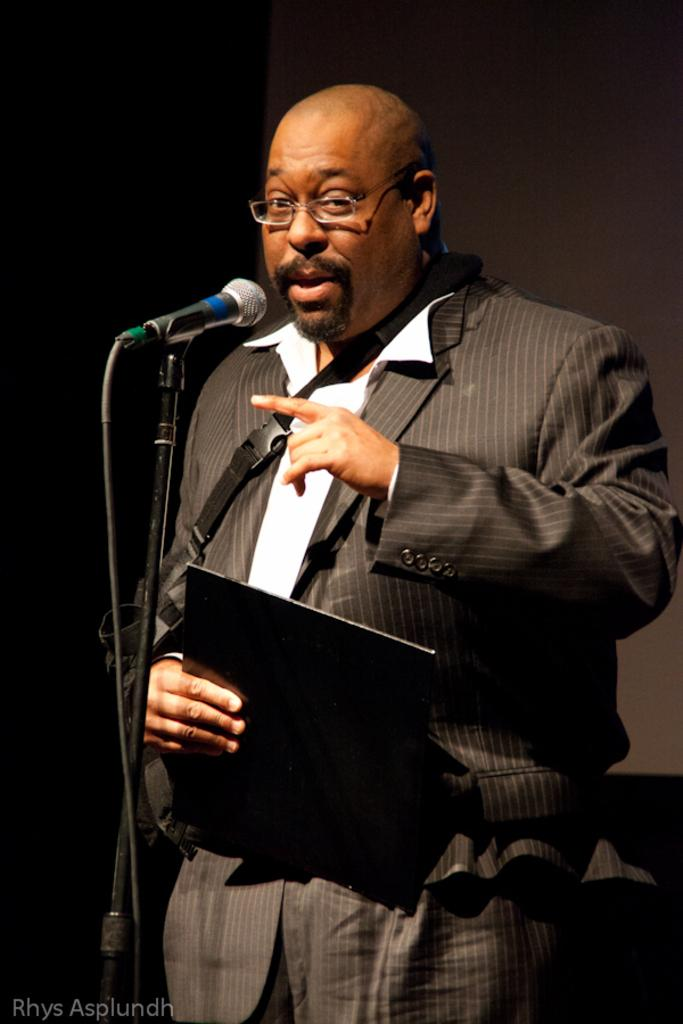Who is the main subject in the image? There is a man in the image. Where is the man located in the image? The man is in the center of the image. What is the man holding in the image? The man is holding a notepad. What object is in front of the man? There is a microphone in front of the man. What type of sack is the man carrying on his back in the image? There is no sack present in the image; the man is holding a notepad and standing in front of a microphone. 